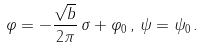<formula> <loc_0><loc_0><loc_500><loc_500>\varphi = - \frac { \sqrt { b } } { 2 \pi } \, \sigma + \varphi _ { 0 } \, , \, \psi = \psi _ { 0 } \, .</formula> 